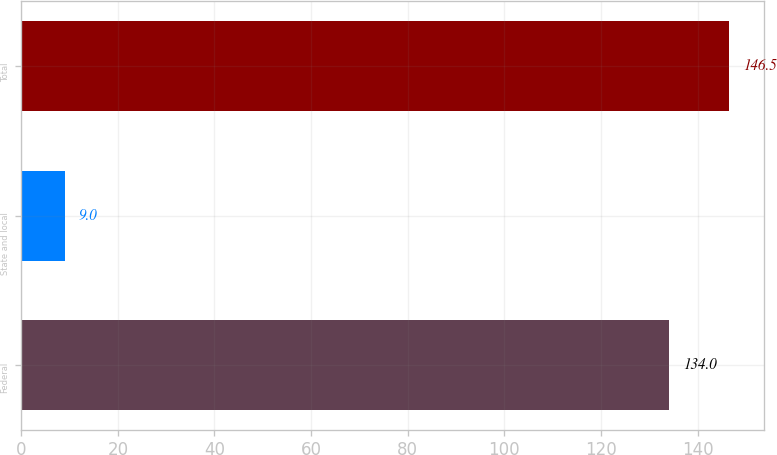Convert chart. <chart><loc_0><loc_0><loc_500><loc_500><bar_chart><fcel>Federal<fcel>State and local<fcel>Total<nl><fcel>134<fcel>9<fcel>146.5<nl></chart> 